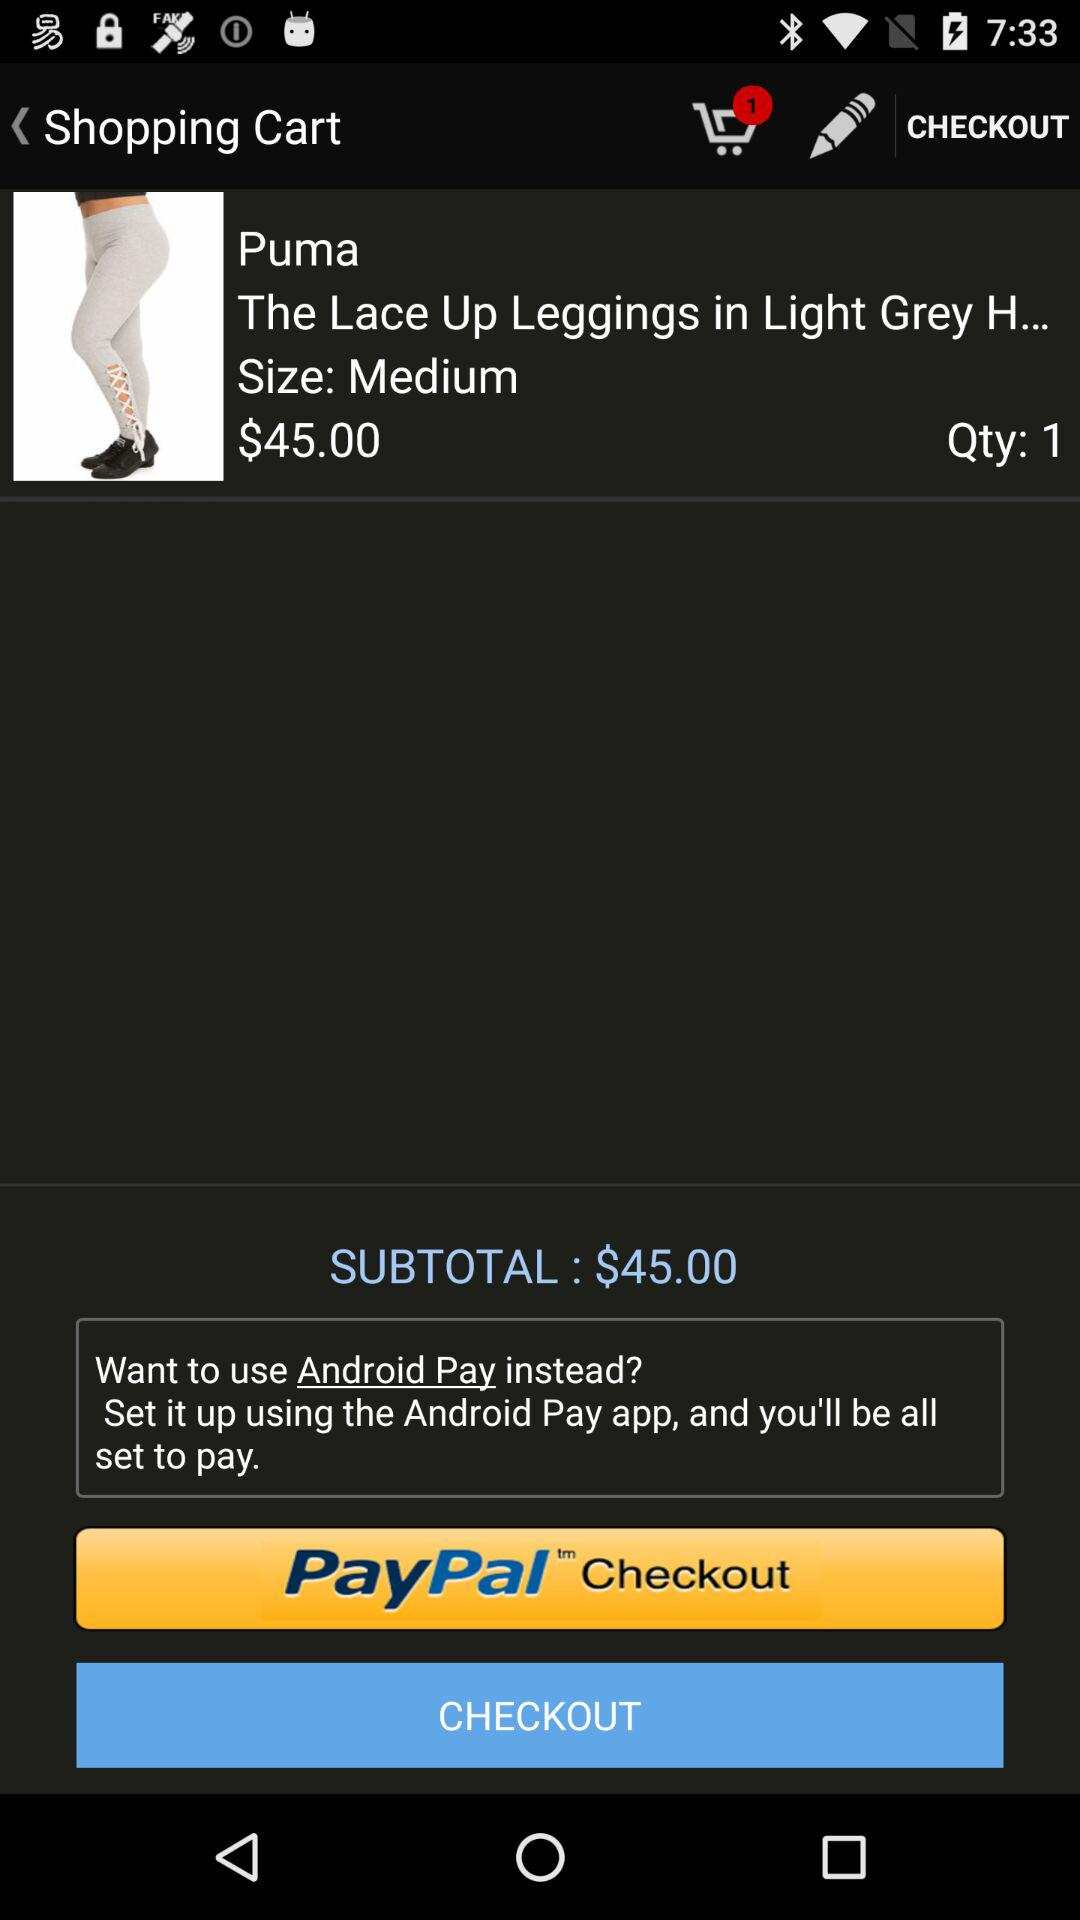What is the brand name? The brand name is Puma. 